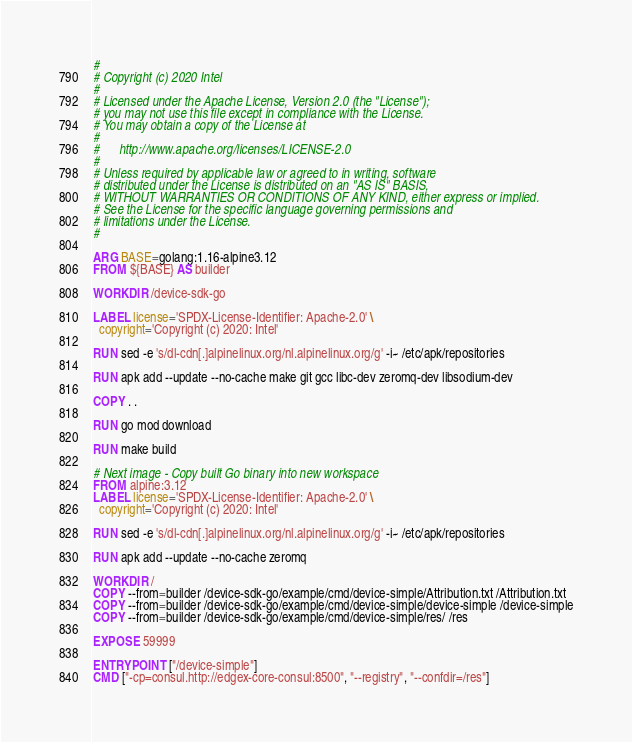Convert code to text. <code><loc_0><loc_0><loc_500><loc_500><_Dockerfile_>#
# Copyright (c) 2020 Intel
#
# Licensed under the Apache License, Version 2.0 (the "License");
# you may not use this file except in compliance with the License.
# You may obtain a copy of the License at
#
#      http://www.apache.org/licenses/LICENSE-2.0
#
# Unless required by applicable law or agreed to in writing, software
# distributed under the License is distributed on an "AS IS" BASIS,
# WITHOUT WARRANTIES OR CONDITIONS OF ANY KIND, either express or implied.
# See the License for the specific language governing permissions and
# limitations under the License.
#

ARG BASE=golang:1.16-alpine3.12
FROM ${BASE} AS builder

WORKDIR /device-sdk-go

LABEL license='SPDX-License-Identifier: Apache-2.0' \
  copyright='Copyright (c) 2020: Intel'

RUN sed -e 's/dl-cdn[.]alpinelinux.org/nl.alpinelinux.org/g' -i~ /etc/apk/repositories

RUN apk add --update --no-cache make git gcc libc-dev zeromq-dev libsodium-dev

COPY . .

RUN go mod download

RUN make build

# Next image - Copy built Go binary into new workspace
FROM alpine:3.12
LABEL license='SPDX-License-Identifier: Apache-2.0' \
  copyright='Copyright (c) 2020: Intel'

RUN sed -e 's/dl-cdn[.]alpinelinux.org/nl.alpinelinux.org/g' -i~ /etc/apk/repositories

RUN apk add --update --no-cache zeromq

WORKDIR /
COPY --from=builder /device-sdk-go/example/cmd/device-simple/Attribution.txt /Attribution.txt
COPY --from=builder /device-sdk-go/example/cmd/device-simple/device-simple /device-simple
COPY --from=builder /device-sdk-go/example/cmd/device-simple/res/ /res

EXPOSE 59999

ENTRYPOINT ["/device-simple"]
CMD ["-cp=consul.http://edgex-core-consul:8500", "--registry", "--confdir=/res"]
</code> 